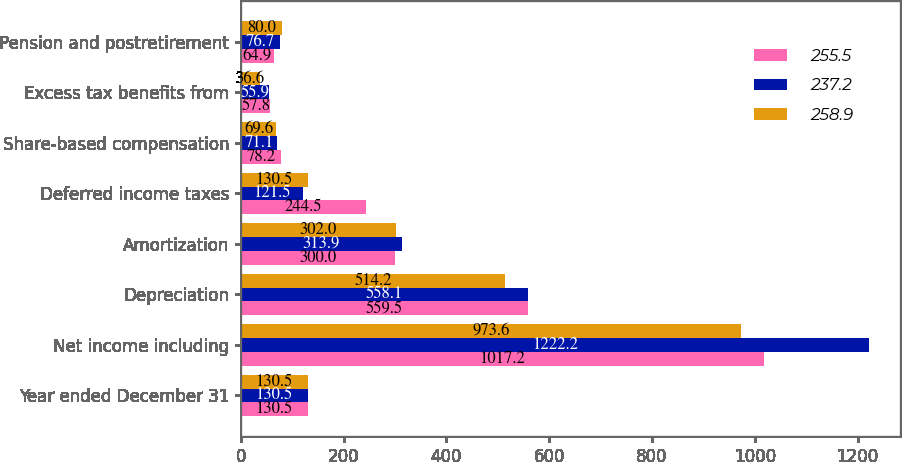<chart> <loc_0><loc_0><loc_500><loc_500><stacked_bar_chart><ecel><fcel>Year ended December 31<fcel>Net income including<fcel>Depreciation<fcel>Amortization<fcel>Deferred income taxes<fcel>Share-based compensation<fcel>Excess tax benefits from<fcel>Pension and postretirement<nl><fcel>255.5<fcel>130.5<fcel>1017.2<fcel>559.5<fcel>300<fcel>244.5<fcel>78.2<fcel>57.8<fcel>64.9<nl><fcel>237.2<fcel>130.5<fcel>1222.2<fcel>558.1<fcel>313.9<fcel>121.5<fcel>71.1<fcel>55.9<fcel>76.7<nl><fcel>258.9<fcel>130.5<fcel>973.6<fcel>514.2<fcel>302<fcel>130.5<fcel>69.6<fcel>36.6<fcel>80<nl></chart> 